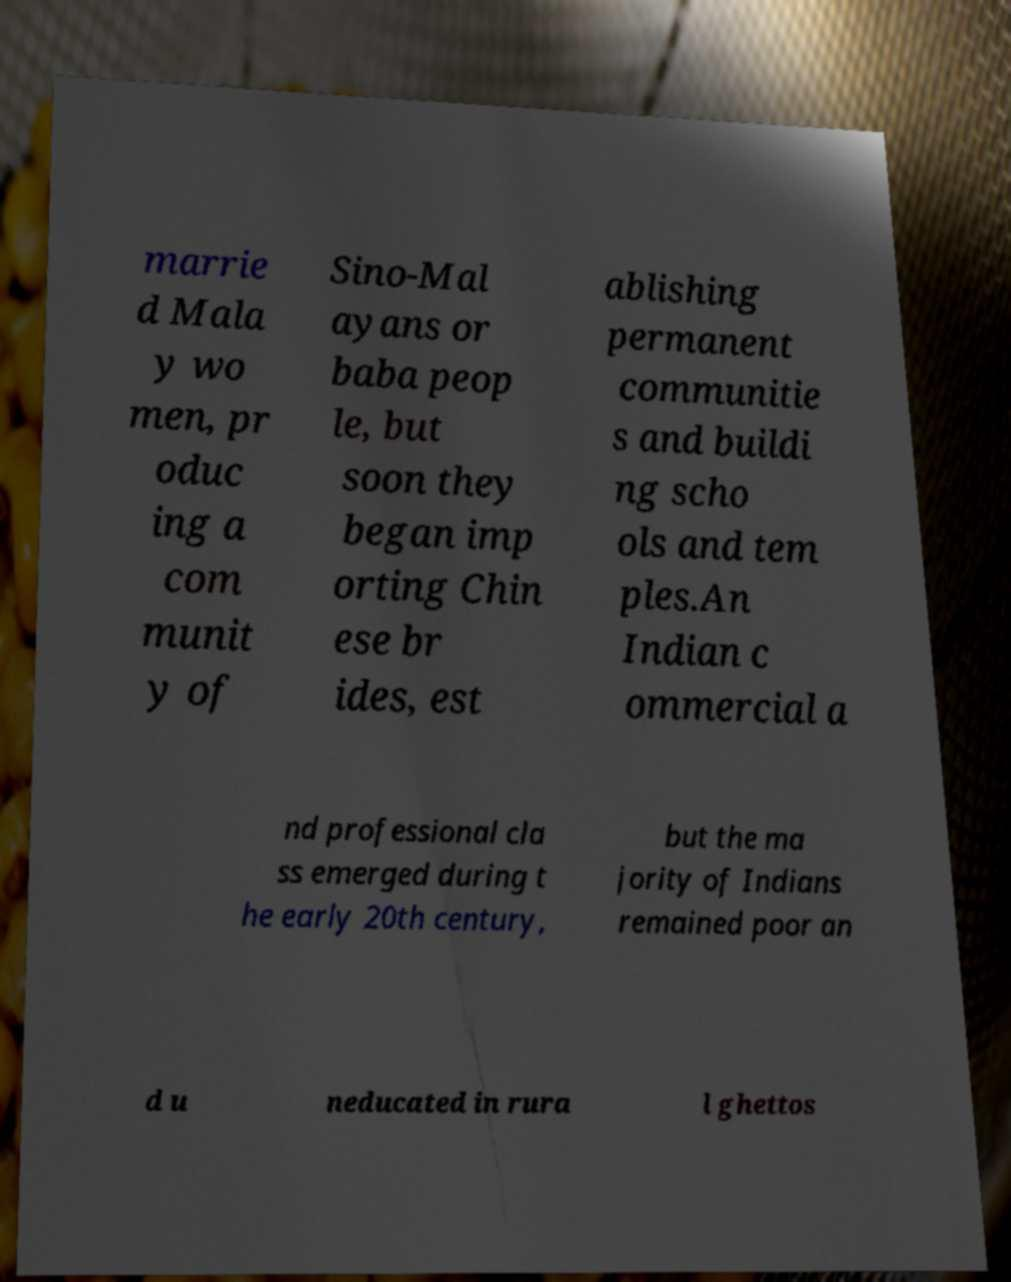Can you read and provide the text displayed in the image?This photo seems to have some interesting text. Can you extract and type it out for me? marrie d Mala y wo men, pr oduc ing a com munit y of Sino-Mal ayans or baba peop le, but soon they began imp orting Chin ese br ides, est ablishing permanent communitie s and buildi ng scho ols and tem ples.An Indian c ommercial a nd professional cla ss emerged during t he early 20th century, but the ma jority of Indians remained poor an d u neducated in rura l ghettos 